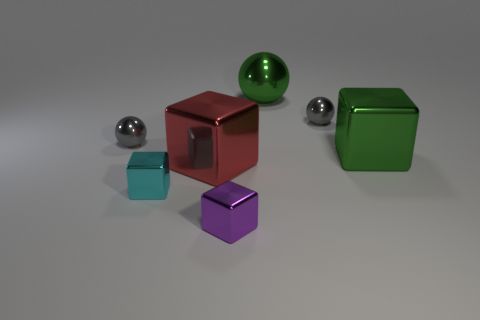Are there any large red balls made of the same material as the large red object?
Offer a terse response. No. Is the size of the purple cube the same as the metallic sphere on the left side of the cyan object?
Your response must be concise. Yes. Are there any large metallic things of the same color as the large metal ball?
Provide a succinct answer. Yes. Is the large red object made of the same material as the tiny purple block?
Your response must be concise. Yes. There is a red shiny thing; how many small blocks are in front of it?
Make the answer very short. 2. What is the material of the thing that is both on the right side of the tiny cyan cube and in front of the big red object?
Provide a short and direct response. Metal. How many brown metallic things have the same size as the cyan thing?
Ensure brevity in your answer.  0. The tiny sphere to the left of the large metal cube that is on the left side of the green metal sphere is what color?
Your response must be concise. Gray. Is there a brown object?
Keep it short and to the point. No. Is the shape of the tiny cyan shiny object the same as the purple shiny thing?
Your response must be concise. Yes. 